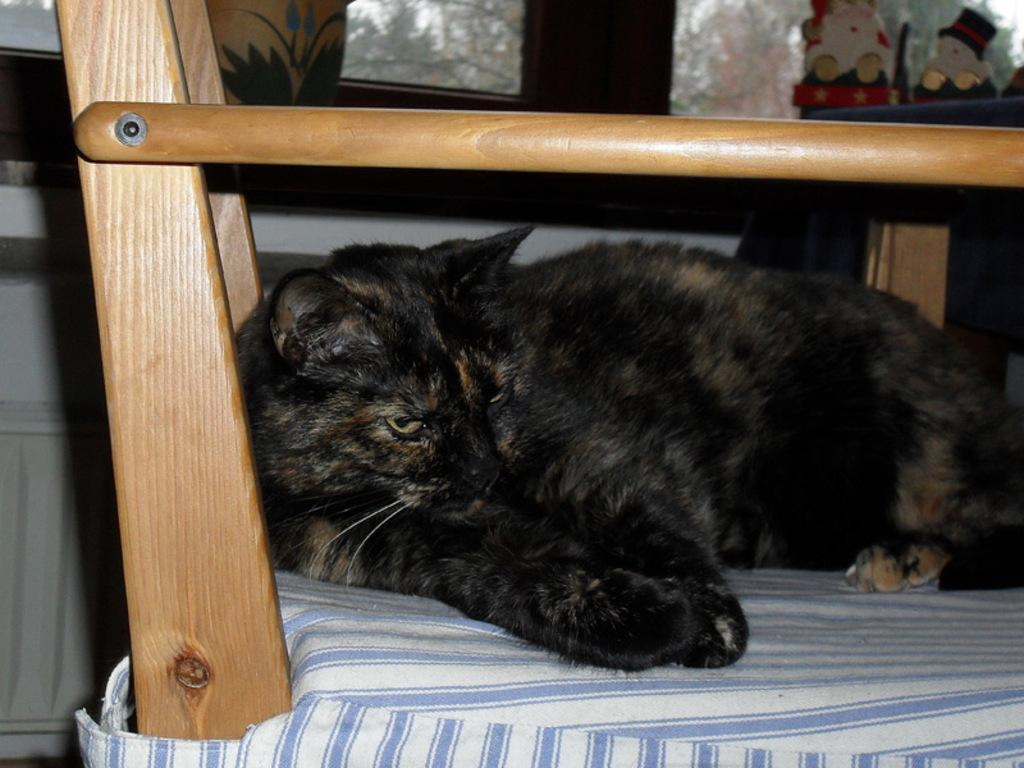What type of animal is laying on the bed in the image? There is a black cat laying on the bed in the image. What material can be seen in the image besides the cat? Wooden sticks are visible in the image. What color is the wall in the background of the image? The background of the image includes a white wall. What type of object can be seen in the background made of glass? There is a glass object in the background. What other objects can be seen in the background? There are other objects in the background. How many fish are swimming in the bowl on the table in the image? There is no bowl of fish present in the image; it features a black cat laying on the bed and other objects in the background. 